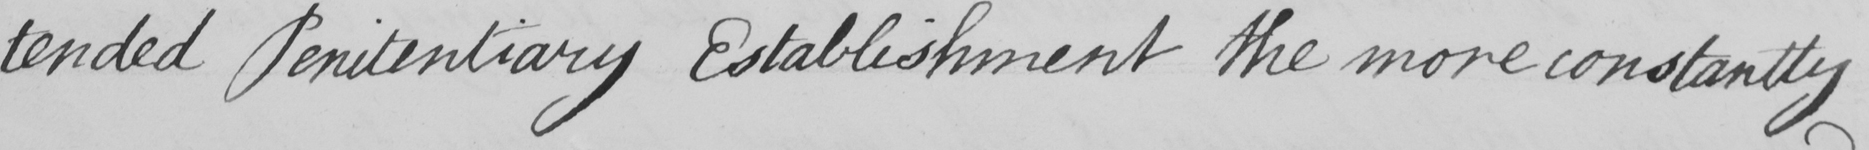Can you read and transcribe this handwriting? -tended Penitentiary Establishment the more constantly 